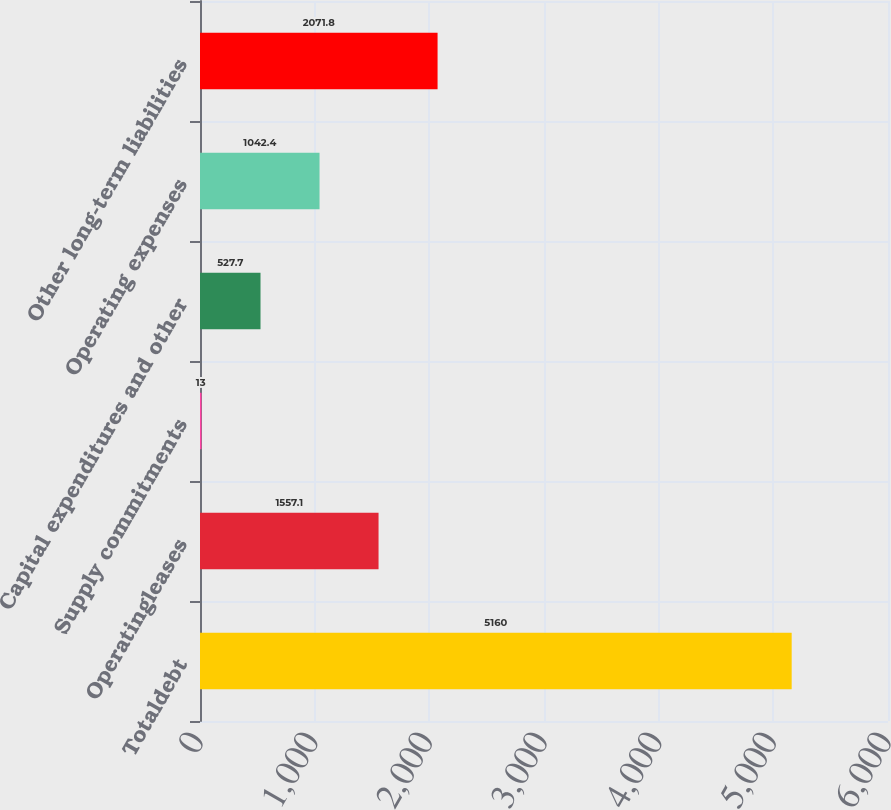Convert chart to OTSL. <chart><loc_0><loc_0><loc_500><loc_500><bar_chart><fcel>Totaldebt<fcel>Operatingleases<fcel>Supply commitments<fcel>Capital expenditures and other<fcel>Operating expenses<fcel>Other long-term liabilities<nl><fcel>5160<fcel>1557.1<fcel>13<fcel>527.7<fcel>1042.4<fcel>2071.8<nl></chart> 